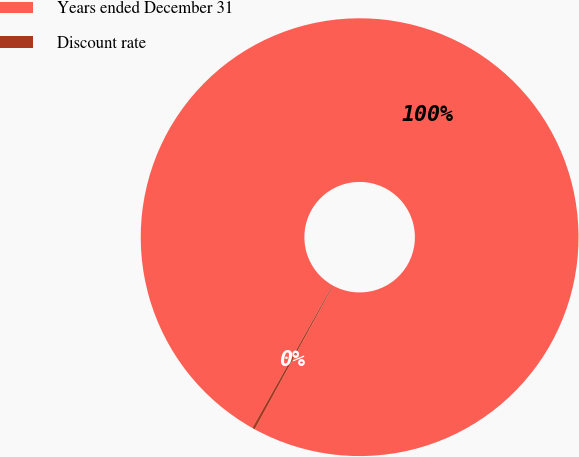Convert chart to OTSL. <chart><loc_0><loc_0><loc_500><loc_500><pie_chart><fcel>Years ended December 31<fcel>Discount rate<nl><fcel>99.8%<fcel>0.2%<nl></chart> 